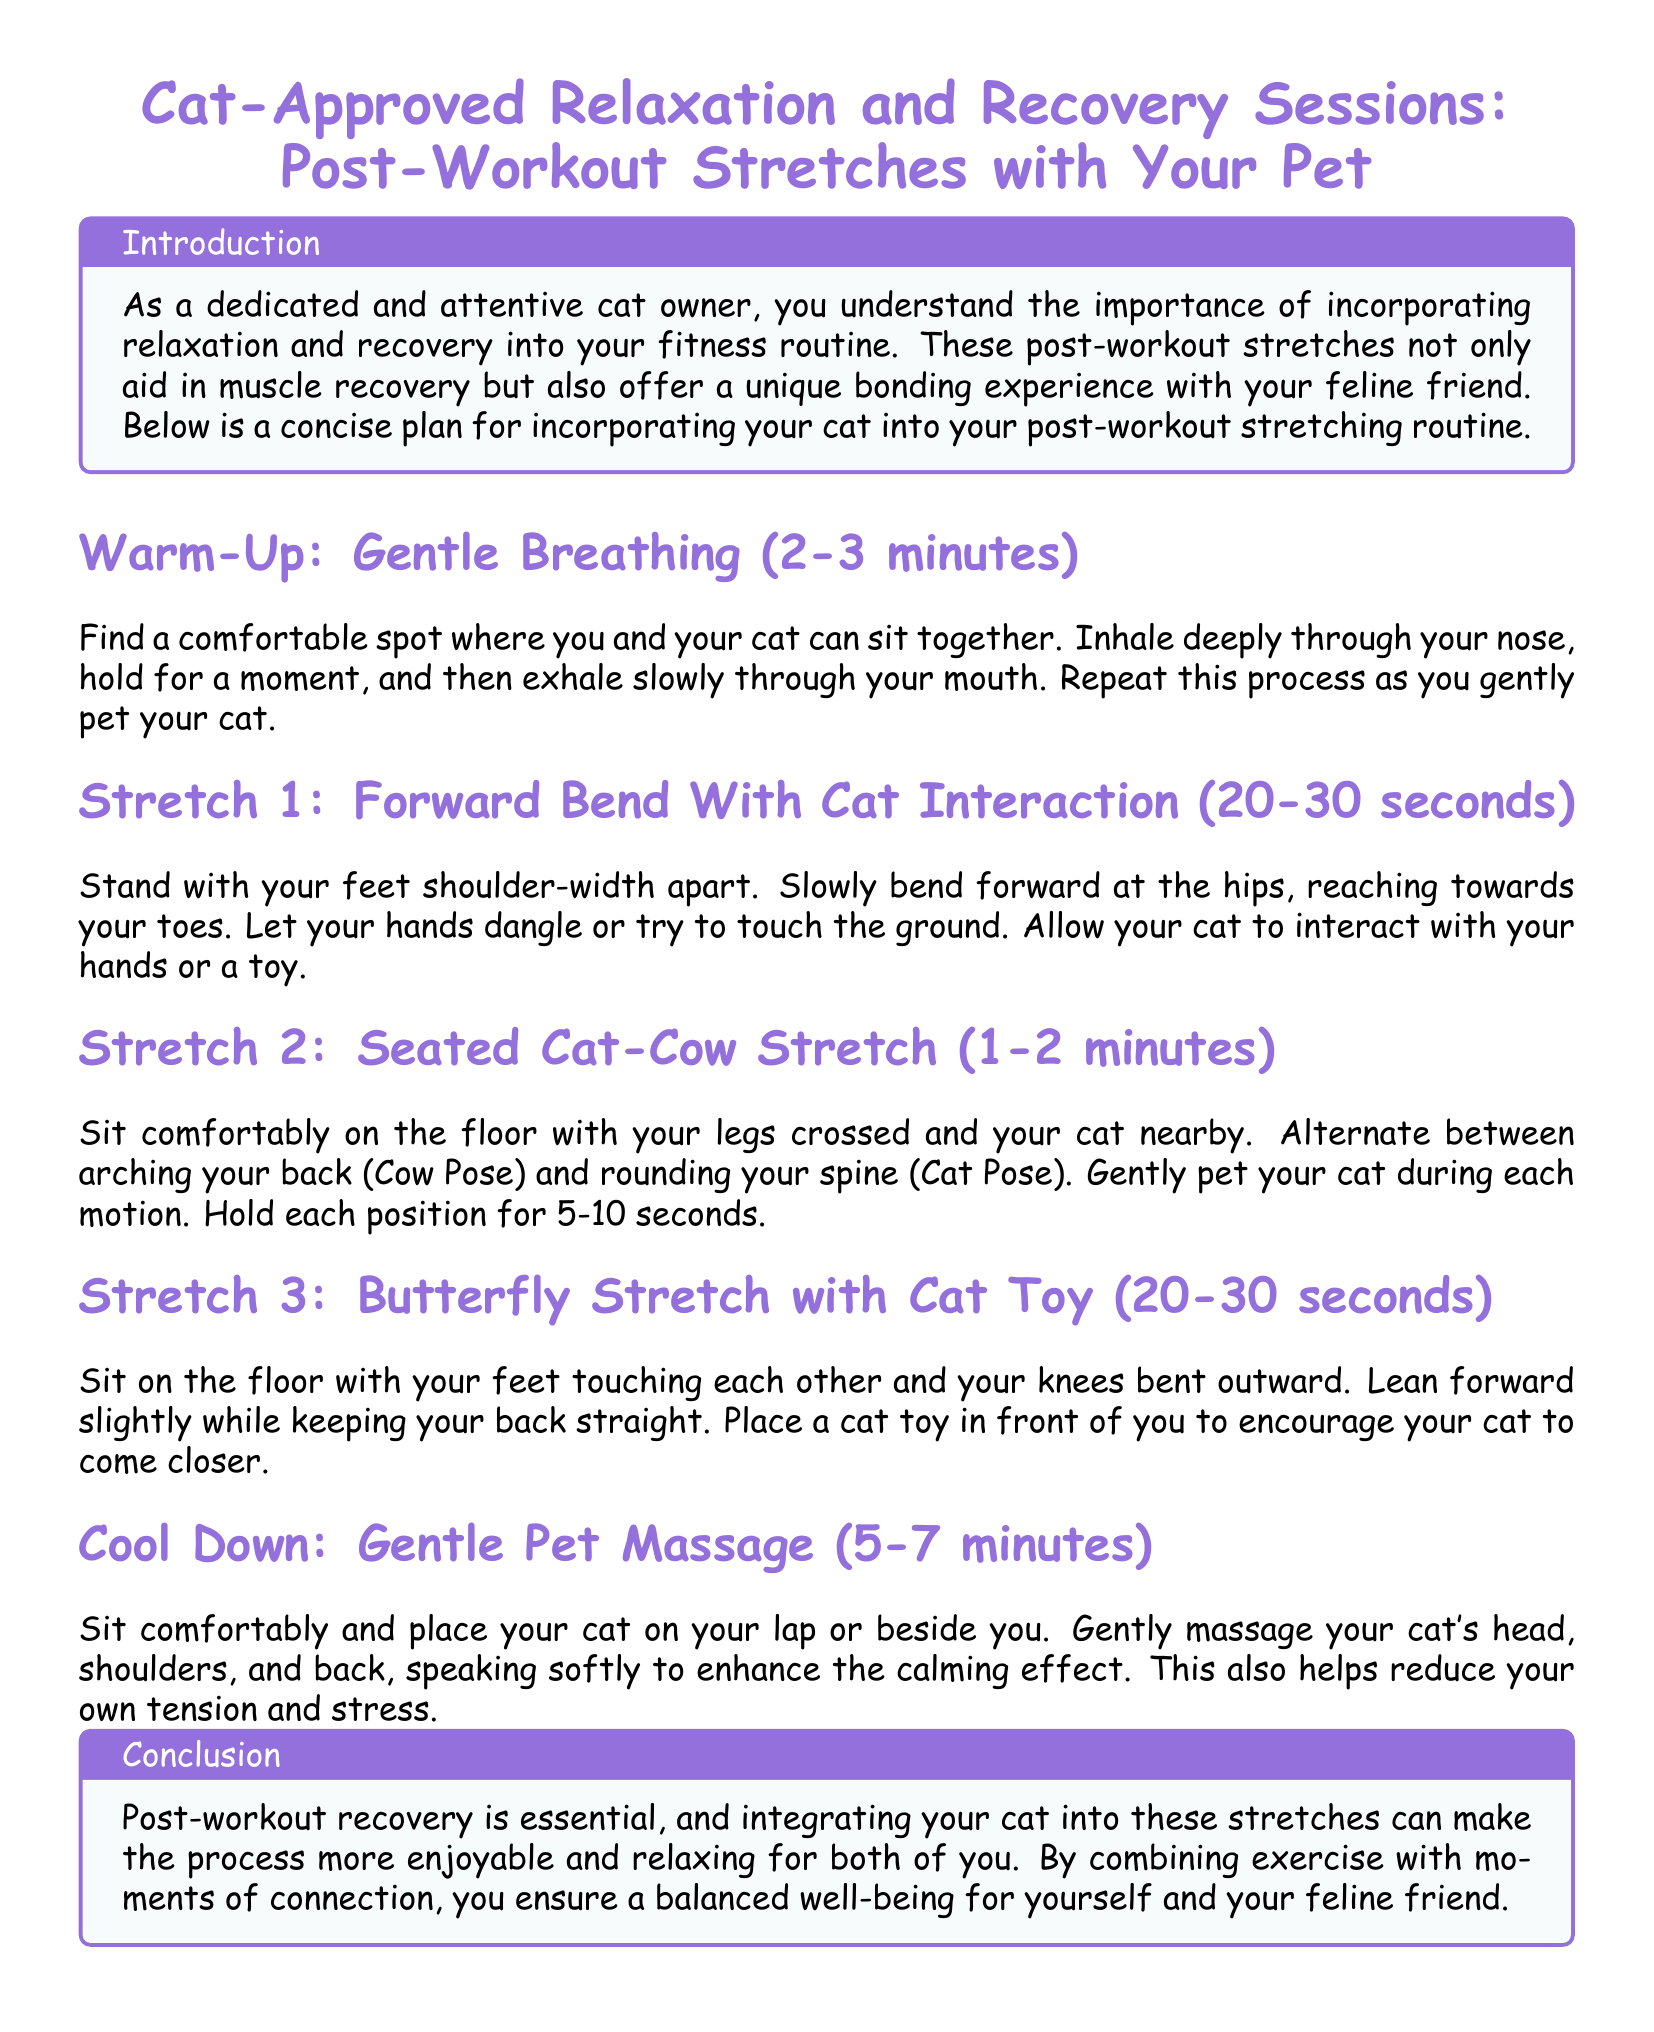What is the title of the document? The title of the document is highlighted at the beginning, stating the main focus on stretches with the pet.
Answer: Cat-Approved Relaxation and Recovery Sessions: Post-Workout Stretches with Your Pet How long should the Gentle Breathing warm-up last? The document specifies the duration for the warm-up section, indicating a specific time for the activity.
Answer: 2-3 minutes What is the duration for the Seated Cat-Cow Stretch? The document outlines the time recommendation for this particular stretch, stating how long it should be performed.
Answer: 1-2 minutes What action should you take during the Forward Bend Stretch? The document explains an activity that involves interaction with the cat while performing the stretch.
Answer: Let your hands dangle or try to touch the ground What is the cool-down activity mentioned in the document? The document highlights a specific post-workout activity that focuses on relaxation with your pet.
Answer: Gentle Pet Massage What is one benefit of the post-workout recovery mentioned? The document discusses a positive outcome of incorporating these activities, emphasizing a particular virtue for both the owner and the pet.
Answer: Bonding experience How should you interact with your cat during the Butterfly Stretch? The document describes a way to engage the cat to enhance the effectiveness of the stretch.
Answer: Place a cat toy in front of you What is the suggested duration for the Gentle Pet Massage? The document provides a specific time frame for this relaxation method.
Answer: 5-7 minutes What is the primary objective of incorporating your cat into the stretching routine? The document highlights an important aspect of integrating your pet in wellness activities.
Answer: Enjoyable and relaxing for both of you 